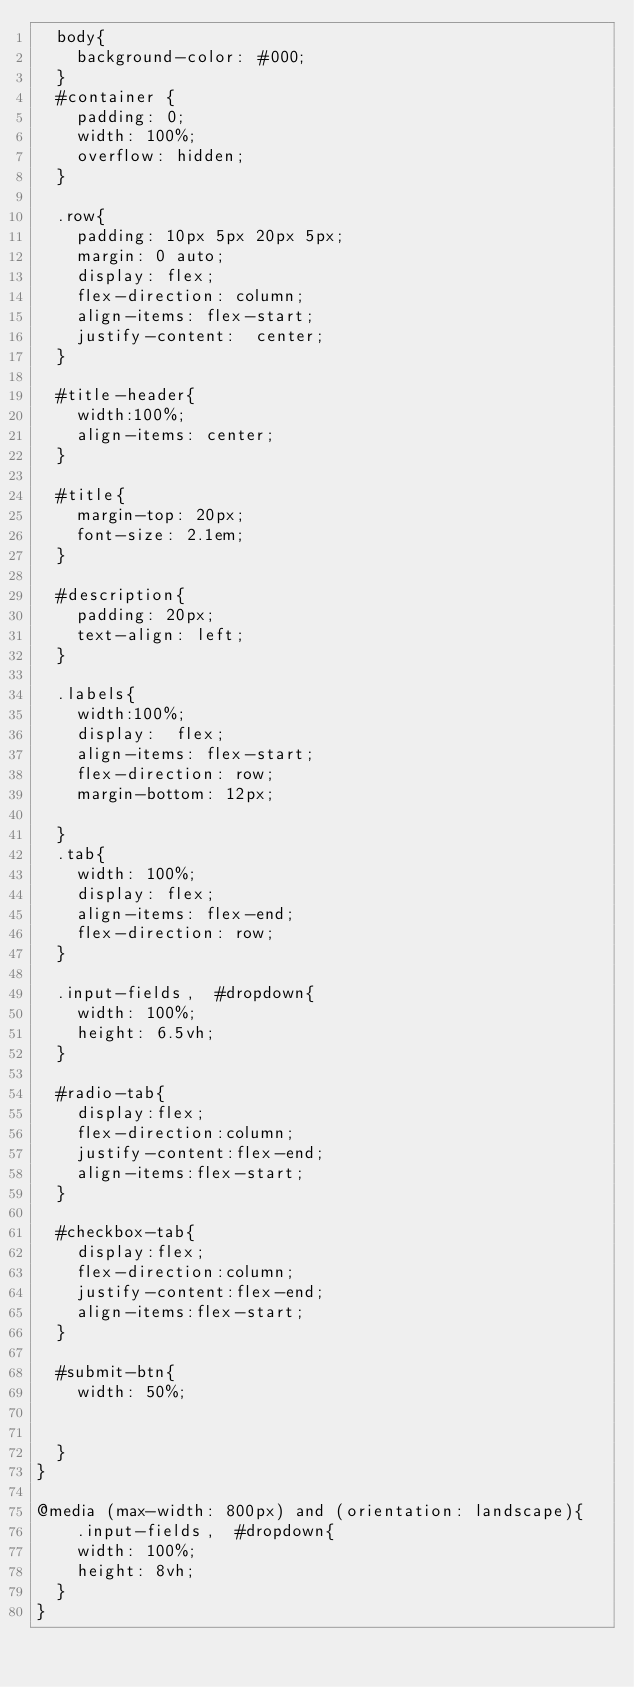Convert code to text. <code><loc_0><loc_0><loc_500><loc_500><_CSS_>	body{
		background-color: #000; 
	}
	#container {
		padding: 0; 
		width: 100%; 
		overflow: hidden; 
	}
	
	.row{
		padding: 10px 5px 20px 5px; 
		margin: 0 auto; 
		display: flex; 
		flex-direction: column; 
		align-items: flex-start; 
		justify-content:  center; 
	}
	
	#title-header{
		width:100%;
		align-items: center;
	}
	
	#title{
		margin-top: 20px;
		font-size: 2.1em; 
	}
	
	#description{
		padding: 20px; 
		text-align: left; 
	}
	
	.labels{
		width:100%;
		display:  flex; 
		align-items: flex-start; 
		flex-direction: row; 
		margin-bottom: 12px; 
		
	}
	.tab{
		width: 100%; 
		display: flex; 
		align-items: flex-end; 
		flex-direction: row; 
	}
	
	.input-fields,  #dropdown{
		width: 100%; 
		height: 6.5vh; 
	}
	
	#radio-tab{
		display:flex;
		flex-direction:column;
		justify-content:flex-end;
		align-items:flex-start;		
	}
	
	#checkbox-tab{
		display:flex;
		flex-direction:column;
		justify-content:flex-end;
		align-items:flex-start;
	}
	
	#submit-btn{
		width: 50%;
		
		 
	}
}

@media (max-width: 800px) and (orientation: landscape){
		.input-fields,  #dropdown{
		width: 100%; 
		height: 8vh; 
	}
}</code> 